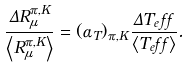Convert formula to latex. <formula><loc_0><loc_0><loc_500><loc_500>\frac { \Delta R ^ { \pi , K } _ { \mu } } { \left < R ^ { \pi , K } _ { \mu } \right > } = ( \alpha _ { T } ) _ { \pi , K } \frac { \Delta T _ { e } f f } { \left < T _ { e } f f \right > } .</formula> 